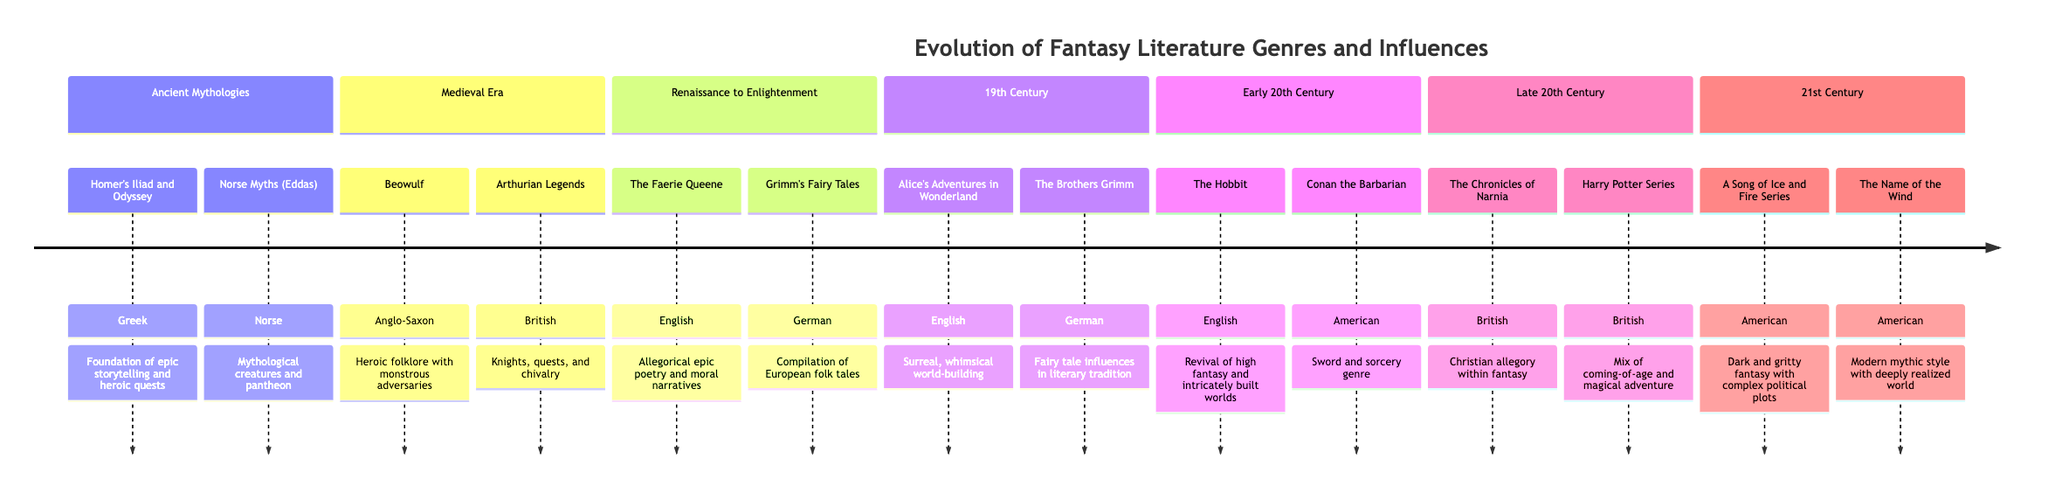What is the first major work listed in the Ancient Mythologies section? The diagram starts with Homer's works in the Ancient Mythologies section, specifically the Iliad and Odyssey, which are foundational texts of epic storytelling.
Answer: Homer's Iliad and Odyssey Which genre is associated with Conan the Barbarian? The diagram explicitly states that Conan the Barbarian is categorized under the Sword and Sorcery genre, which is a key subgenre of fantasy literature.
Answer: Sword and sorcery How many major authors are mentioned in the Late 20th Century section? In the Late 20th Century section, there are two major works listed: The Chronicles of Narnia and the Harry Potter Series, each associated with its respective authors.
Answer: 2 What cultural impact does The Faerie Queene have according to the diagram? The diagram indicates that The Faerie Queene contributed to allegorical epic poetry and moral narratives, which highlights its cultural impact during the Renaissance.
Answer: Allegorical epic poetry and moral narratives Which book is credited with the revival of high fantasy? The diagram explicitly states that The Hobbit is the work credited with the revival of high fantasy, marking a significant turning point in the genre's development.
Answer: The Hobbit What does the A Song of Ice and Fire Series represent within modern fantasy? According to the diagram, A Song of Ice and Fire Series is characterized as dark and gritty fantasy, highlighting its complex political plots and mature themes in modern literature.
Answer: Dark and gritty fantasy How many sections are in the diagram? The diagram contains six distinct sections, each delineating different eras in the evolution of fantasy literature, from Ancient Mythologies to the 21st Century.
Answer: 6 What is the primary theme of Alice's Adventures in Wonderland? The diagram identifies the theme of Alice's Adventures in Wonderland as surreal and whimsical world-building, illustrating its distinctive qualities in literature.
Answer: Surreal, whimsical world-building How does the Harry Potter Series blend genres? The diagram explains that the Harry Potter Series mixes coming-of-age themes with magical adventure, showcasing its dual appeal in storytelling.
Answer: Coming-of-age and magical adventure 